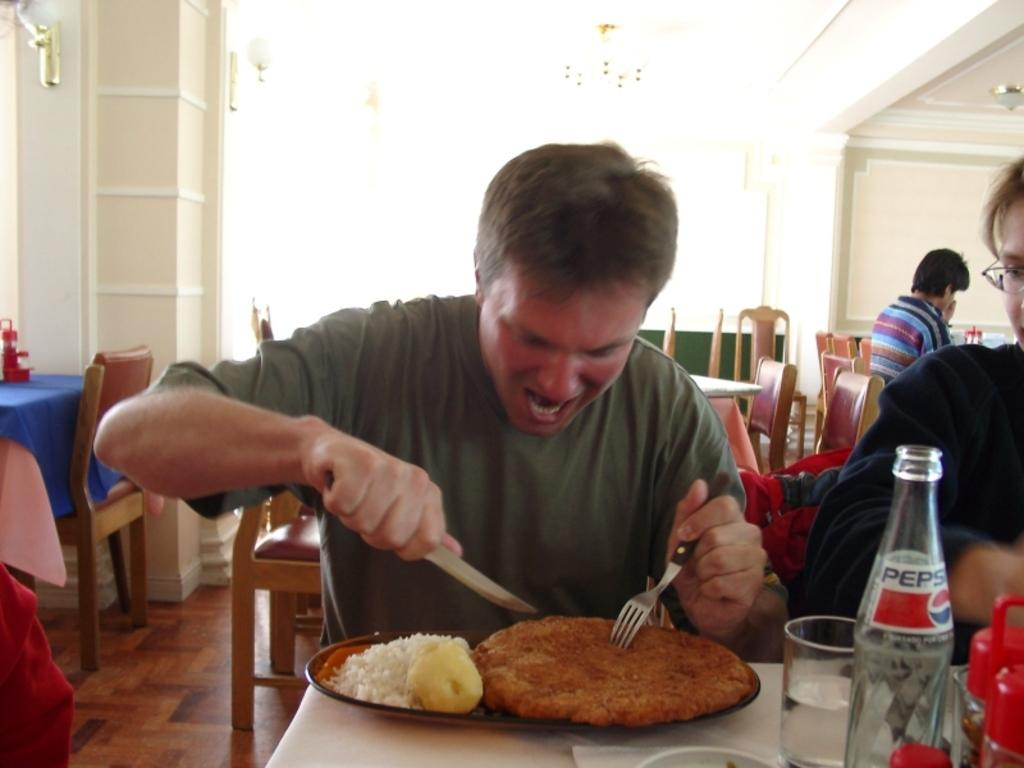<image>
Summarize the visual content of the image. A man is cutting into some food and there is a Pepsi bottle next to him. 